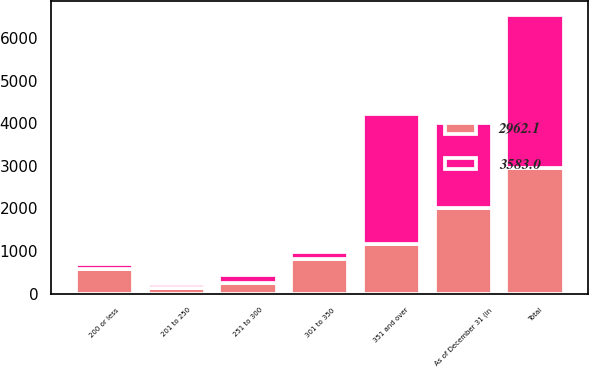Convert chart. <chart><loc_0><loc_0><loc_500><loc_500><stacked_bar_chart><ecel><fcel>As of December 31 (in<fcel>200 or less<fcel>201 to 250<fcel>251 to 300<fcel>301 to 350<fcel>351 and over<fcel>Total<nl><fcel>3583<fcel>2006<fcel>116.7<fcel>92.6<fcel>167.6<fcel>160.8<fcel>3045.3<fcel>3583<nl><fcel>2962.1<fcel>2005<fcel>571.1<fcel>143.8<fcel>261.8<fcel>817.7<fcel>1167.7<fcel>2962.1<nl></chart> 